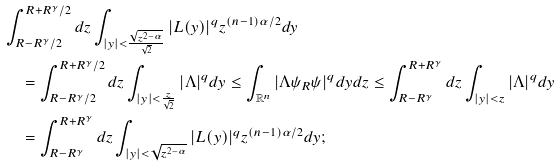Convert formula to latex. <formula><loc_0><loc_0><loc_500><loc_500>& \int _ { R - R ^ { \gamma } / 2 } ^ { R + R ^ { \gamma } / 2 } d z \int _ { | y | < \frac { \sqrt { z ^ { 2 - \alpha } } } { \sqrt { 2 } } } | L ( y ) | ^ { q } z ^ { ( n - 1 ) \alpha / 2 } d y \\ & \quad = \int _ { R - R ^ { \gamma } / 2 } ^ { R + R ^ { \gamma } / 2 } d z \int _ { | y | < \frac { z } { \sqrt { 2 } } } | \Lambda | ^ { q } d y \leq \int _ { \mathbb { R } ^ { n } } | \Lambda \psi _ { R } \psi | ^ { q } d y d z \leq \int _ { R - R ^ { \gamma } } ^ { R + R ^ { \gamma } } d z \int _ { | y | < z } | \Lambda | ^ { q } d y \\ & \quad = \int _ { R - R ^ { \gamma } } ^ { R + R ^ { \gamma } } d z \int _ { | y | < \sqrt { z ^ { 2 - \alpha } } } | L ( y ) | ^ { q } z ^ { ( n - 1 ) \alpha / 2 } d y ;</formula> 